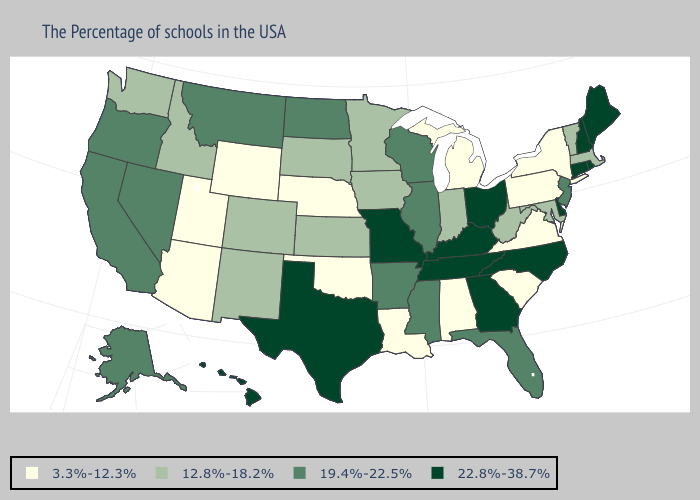How many symbols are there in the legend?
Write a very short answer. 4. What is the value of Arizona?
Quick response, please. 3.3%-12.3%. Does Indiana have a higher value than North Dakota?
Keep it brief. No. How many symbols are there in the legend?
Give a very brief answer. 4. Name the states that have a value in the range 3.3%-12.3%?
Write a very short answer. New York, Pennsylvania, Virginia, South Carolina, Michigan, Alabama, Louisiana, Nebraska, Oklahoma, Wyoming, Utah, Arizona. Among the states that border Nebraska , which have the lowest value?
Be succinct. Wyoming. Name the states that have a value in the range 12.8%-18.2%?
Give a very brief answer. Massachusetts, Vermont, Maryland, West Virginia, Indiana, Minnesota, Iowa, Kansas, South Dakota, Colorado, New Mexico, Idaho, Washington. What is the value of North Dakota?
Quick response, please. 19.4%-22.5%. What is the value of Vermont?
Write a very short answer. 12.8%-18.2%. What is the value of Kansas?
Keep it brief. 12.8%-18.2%. Which states have the highest value in the USA?
Give a very brief answer. Maine, Rhode Island, New Hampshire, Connecticut, Delaware, North Carolina, Ohio, Georgia, Kentucky, Tennessee, Missouri, Texas, Hawaii. Does Pennsylvania have the highest value in the USA?
Write a very short answer. No. Among the states that border Mississippi , which have the lowest value?
Quick response, please. Alabama, Louisiana. Name the states that have a value in the range 12.8%-18.2%?
Short answer required. Massachusetts, Vermont, Maryland, West Virginia, Indiana, Minnesota, Iowa, Kansas, South Dakota, Colorado, New Mexico, Idaho, Washington. 